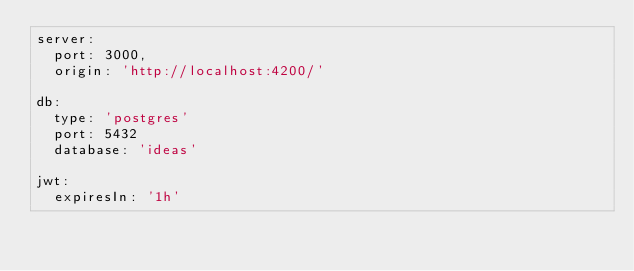<code> <loc_0><loc_0><loc_500><loc_500><_YAML_>server: 
  port: 3000,
  origin: 'http://localhost:4200/'

db: 
  type: 'postgres'
  port: 5432
  database: 'ideas'
  
jwt: 
  expiresIn: '1h'
</code> 